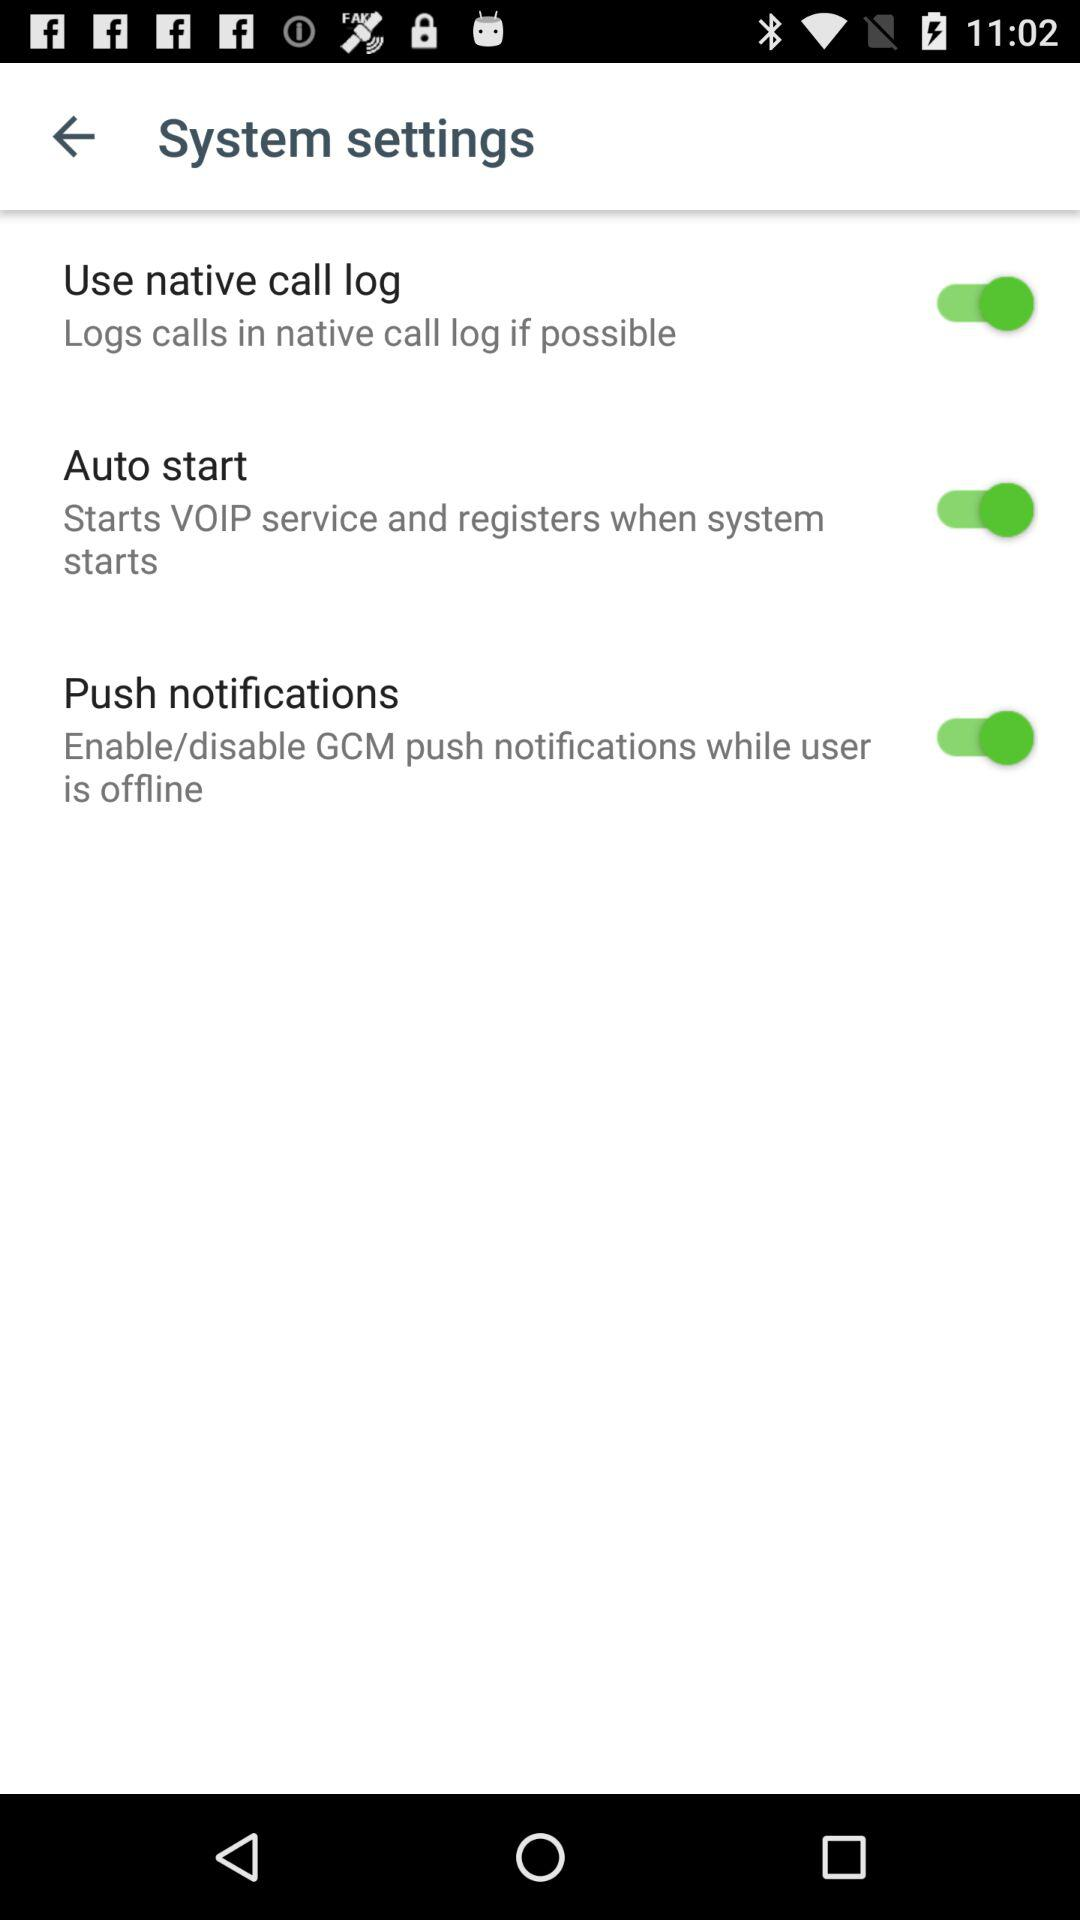What is the status of the "native call log"? The status of the "native call log" is "on". 